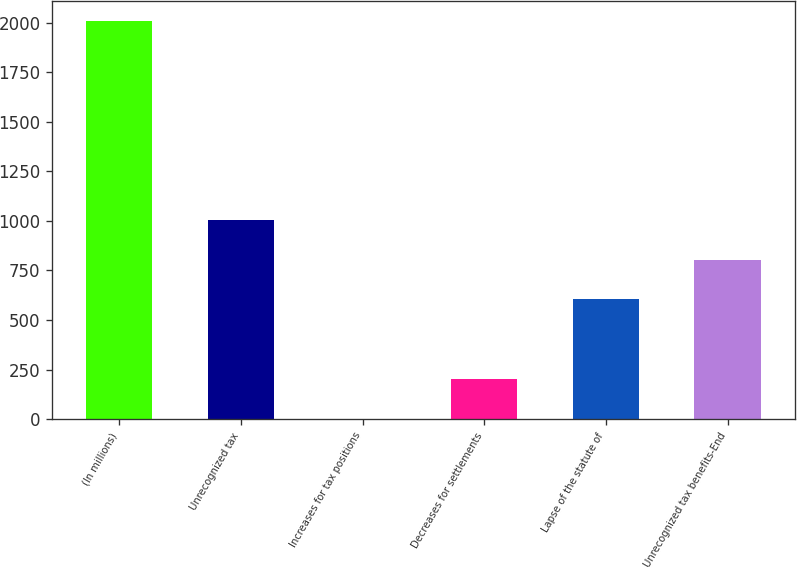<chart> <loc_0><loc_0><loc_500><loc_500><bar_chart><fcel>(In millions)<fcel>Unrecognized tax<fcel>Increases for tax positions<fcel>Decreases for settlements<fcel>Lapse of the statute of<fcel>Unrecognized tax benefits-End<nl><fcel>2010<fcel>1005.5<fcel>1<fcel>201.9<fcel>603.7<fcel>804.6<nl></chart> 